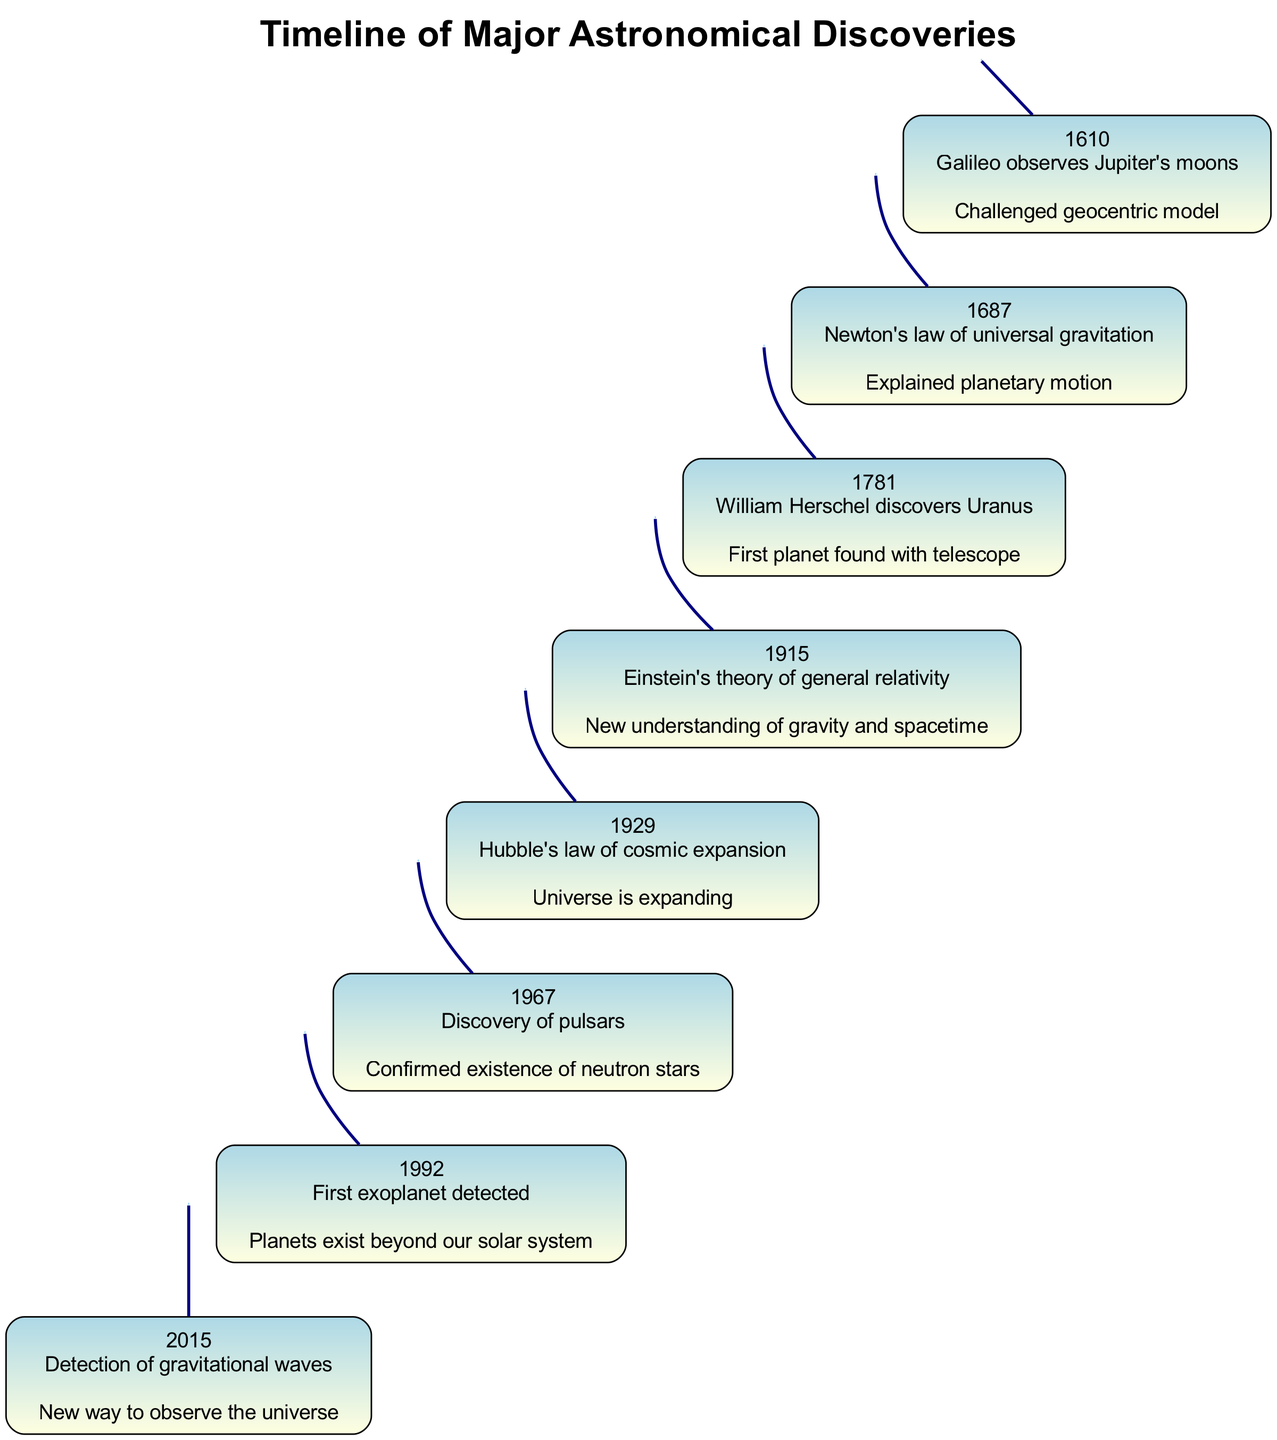What discovery was made in 1781? The diagram lists the events chronologically, with each event showing the year, discovery, and significance. The event for the year 1781 indicates that William Herschel discovered Uranus.
Answer: William Herschel discovers Uranus What year did Einstein's theory of general relativity occur? The diagram provides specific years linked to significant discoveries. By reviewing the vertical layout, it's noted that Einstein's theory of general relativity occurred in 1915.
Answer: 1915 How many major astronomical discoveries are presented in total? Counting the number of event entries in the diagram, there are eight separate events laid out in the timeline representing significant discoveries in astronomy.
Answer: 8 What was the significance of the discovery made in 1967? By examining the 1967 event in the diagram, it describes the discovery of pulsars, highlighting that it confirmed the existence of neutron stars.
Answer: Confirmed existence of neutron stars Which discovery challenged the geocentric model? Looking through the events, the discovery listed in 1610 by Galileo, which involved observing Jupiter's moons, is noted for challenging the geocentric model of the universe.
Answer: Galileo observes Jupiter's moons What is the smooth scrolling feature for mobile adaptation? The diagram describes mobile adaptations with interactive features, including a smooth vertical scroll for easier navigation on mobile devices.
Answer: Smooth vertical scroll What discovery was made in the year 2015? Referring to the timeline, 2015 was marked by the detection of gravitational waves, a significant event in modern astronomy.
Answer: Detection of gravitational waves Which event confirmed the existence of neutron stars? Upon examining the events, the one listed for 1967 is the discovery of pulsars, which specifically confirms the existence of neutron stars.
Answer: Discovery of pulsars 